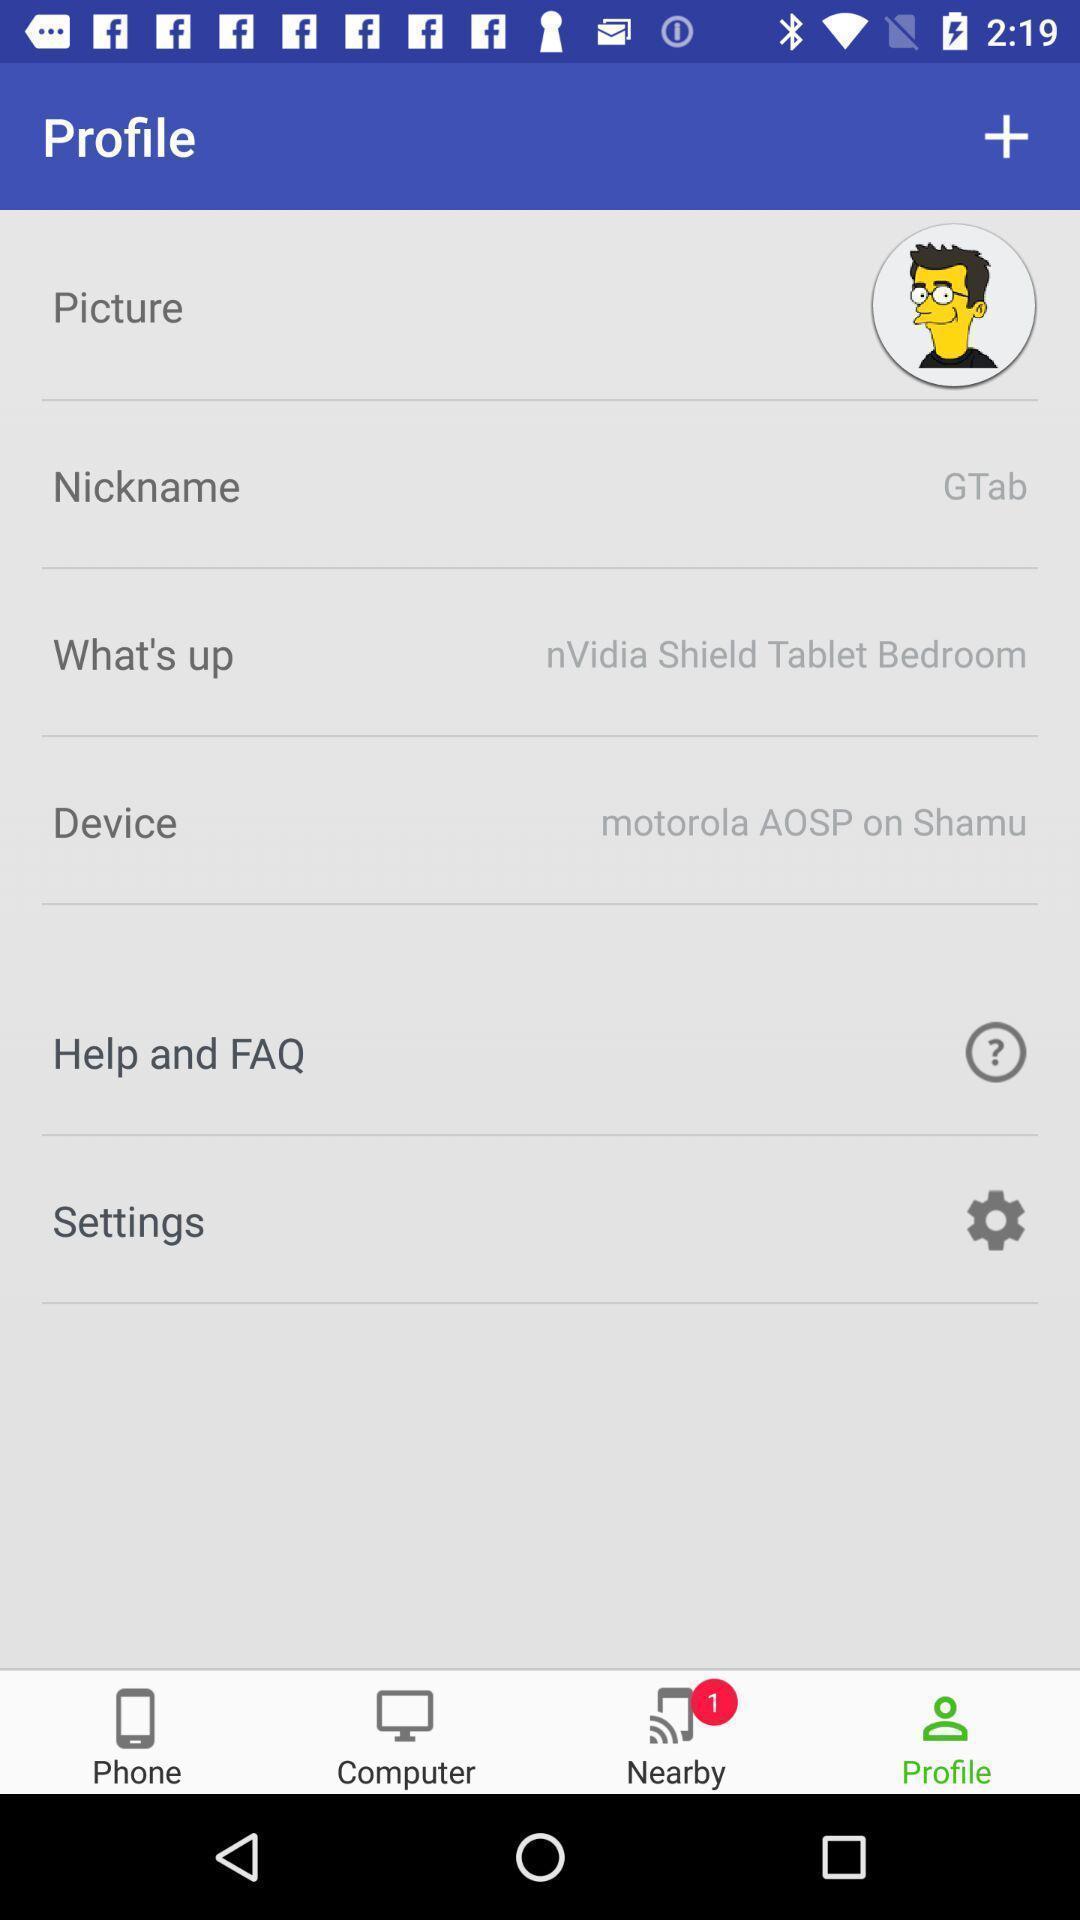What is the overall content of this screenshot? Page displaying to enter personal information in app. 